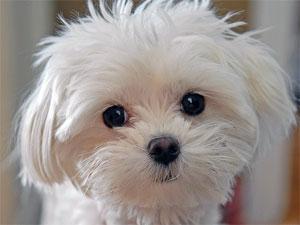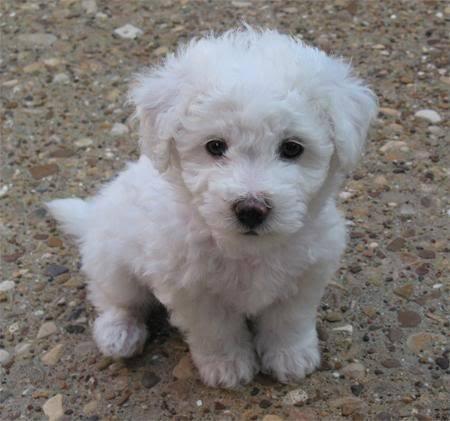The first image is the image on the left, the second image is the image on the right. Analyze the images presented: Is the assertion "At least one of the dogs has its tongue sticking out." valid? Answer yes or no. No. The first image is the image on the left, the second image is the image on the right. Examine the images to the left and right. Is the description "Dogs are sticking out their tongues far enough for the tongues to be visible." accurate? Answer yes or no. No. 